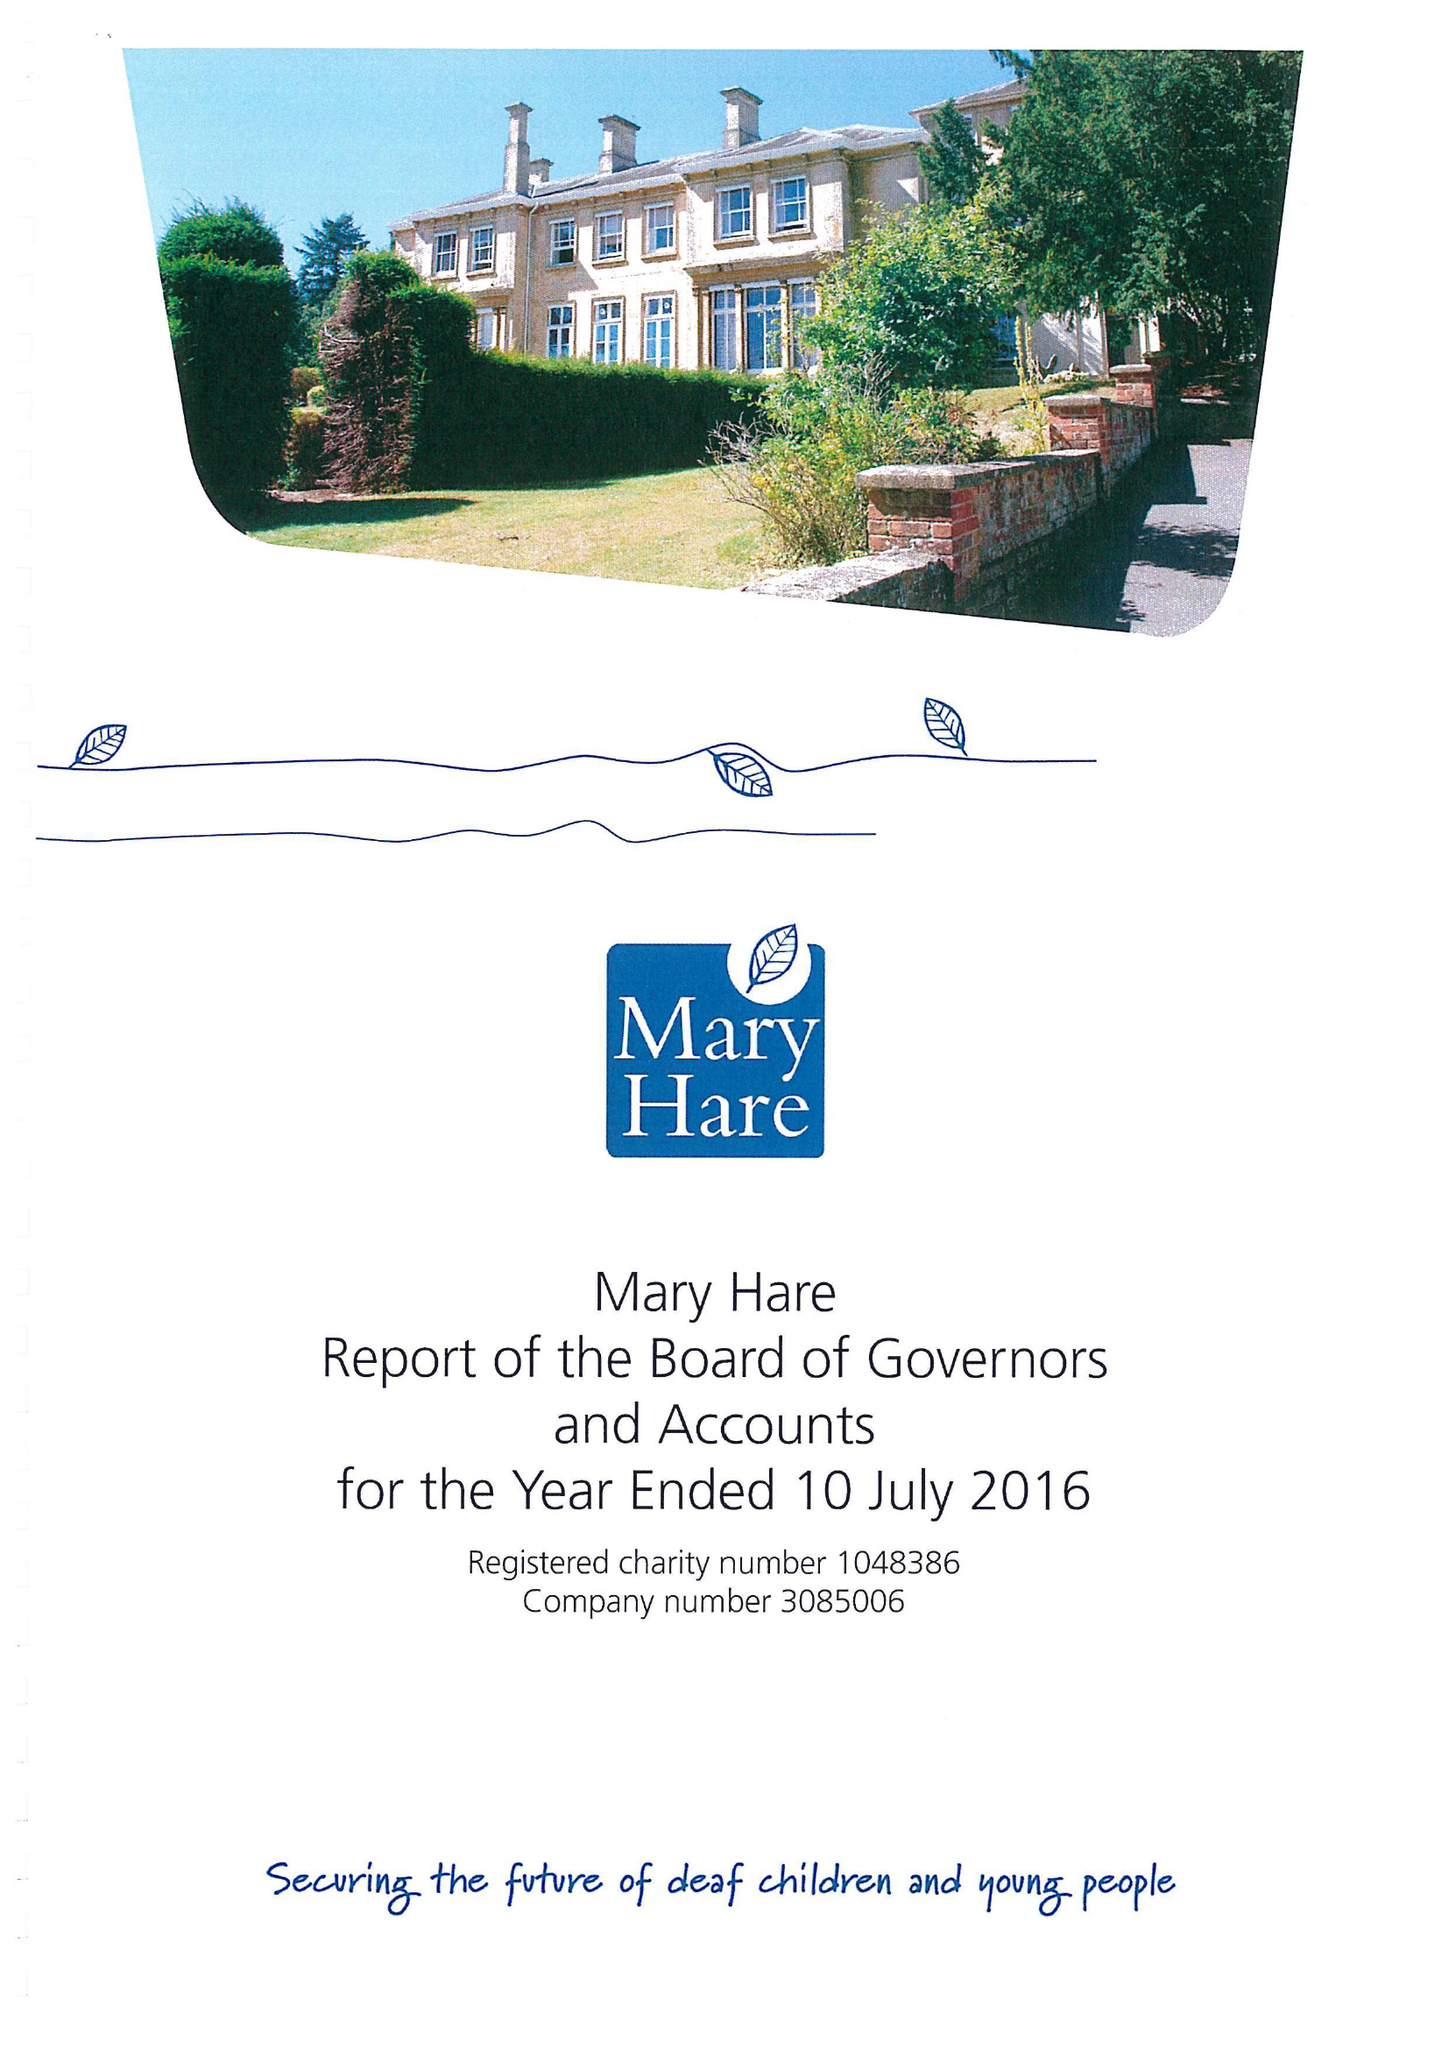What is the value for the address__postcode?
Answer the question using a single word or phrase. RG14 3BQ 